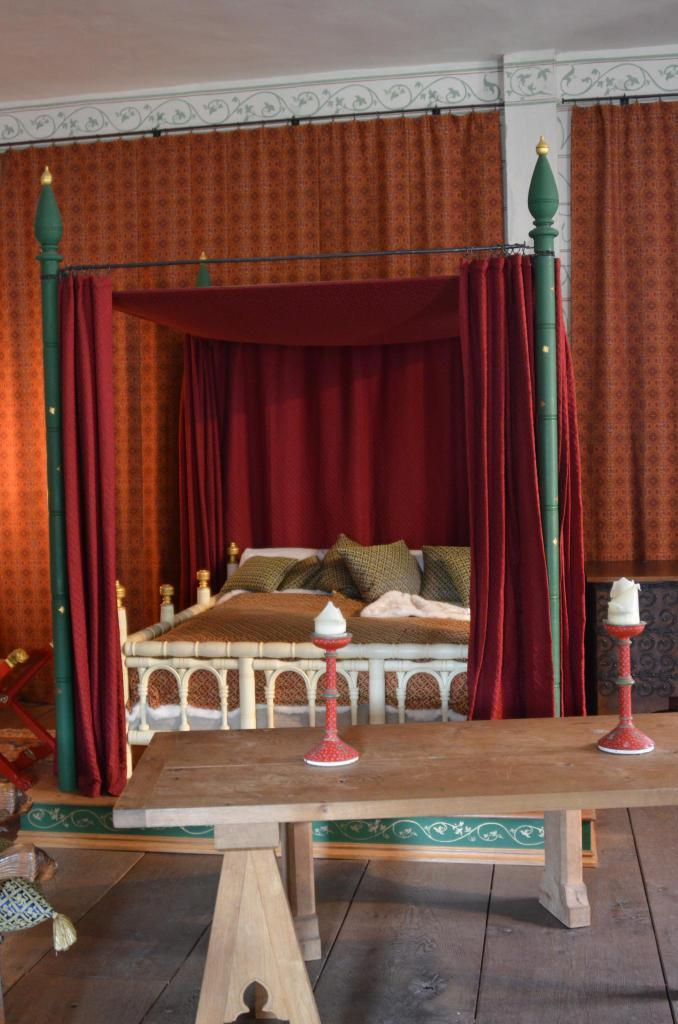What type of furniture is present in the image? There is a table in the image. How many items are on the table? There are two items on the table. What type of seating is visible in the image? There are pillows in the image. What type of bed is present in the image? There is a four-poster bed in the image. What type of window treatment is present in the image? There are curtains in the image. What is visible in the background of the image? There is a wall in the background of the image. What color is the balloon floating above the bed in the image? There is no balloon present in the image. What suggestion is being made by the person in the image? There is no person present in the image, so no suggestion can be made. 